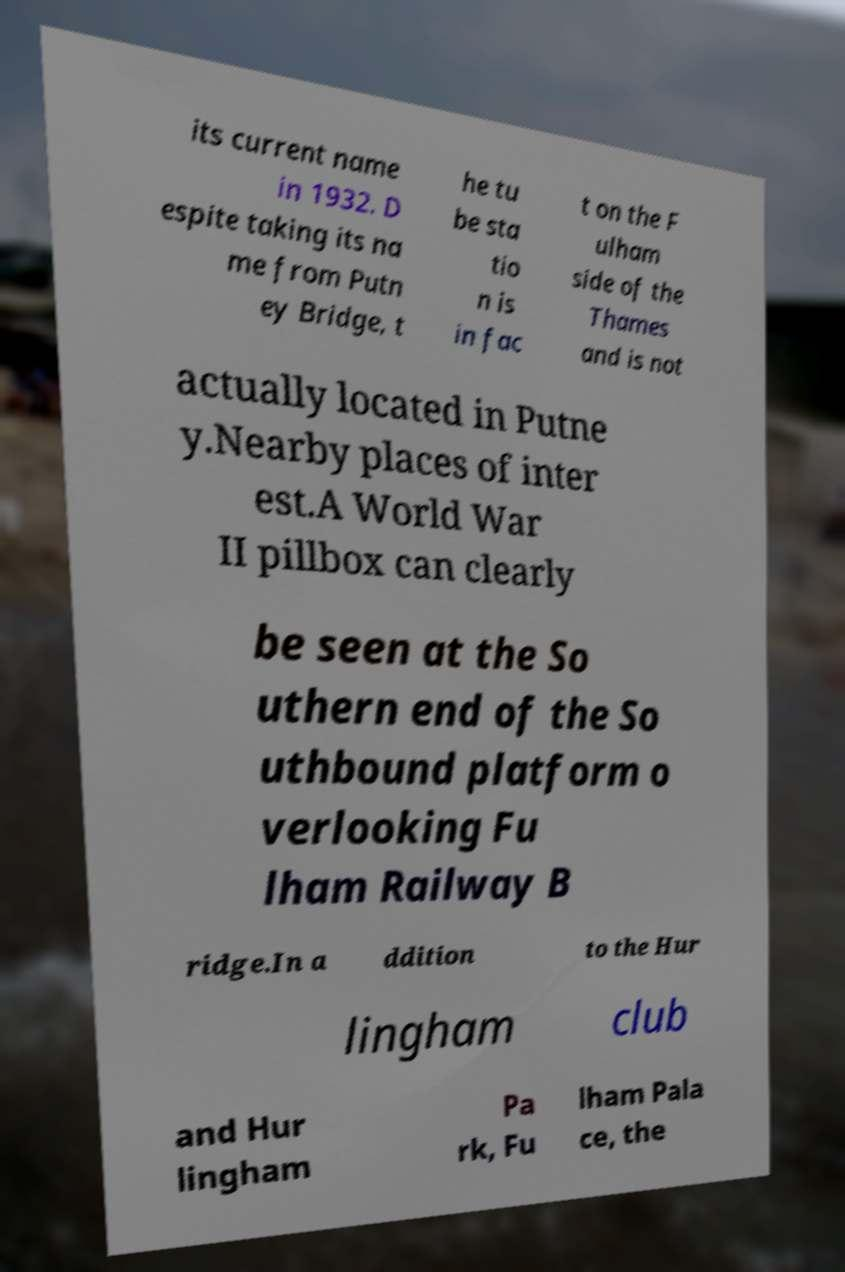For documentation purposes, I need the text within this image transcribed. Could you provide that? its current name in 1932. D espite taking its na me from Putn ey Bridge, t he tu be sta tio n is in fac t on the F ulham side of the Thames and is not actually located in Putne y.Nearby places of inter est.A World War II pillbox can clearly be seen at the So uthern end of the So uthbound platform o verlooking Fu lham Railway B ridge.In a ddition to the Hur lingham club and Hur lingham Pa rk, Fu lham Pala ce, the 